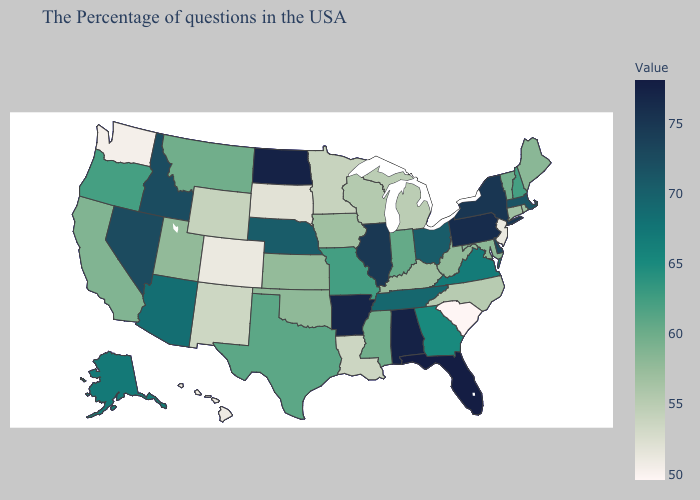Does Indiana have the lowest value in the MidWest?
Quick response, please. No. Does Louisiana have the highest value in the USA?
Give a very brief answer. No. Does New Hampshire have the highest value in the Northeast?
Quick response, please. No. Among the states that border Washington , does Oregon have the highest value?
Short answer required. No. 